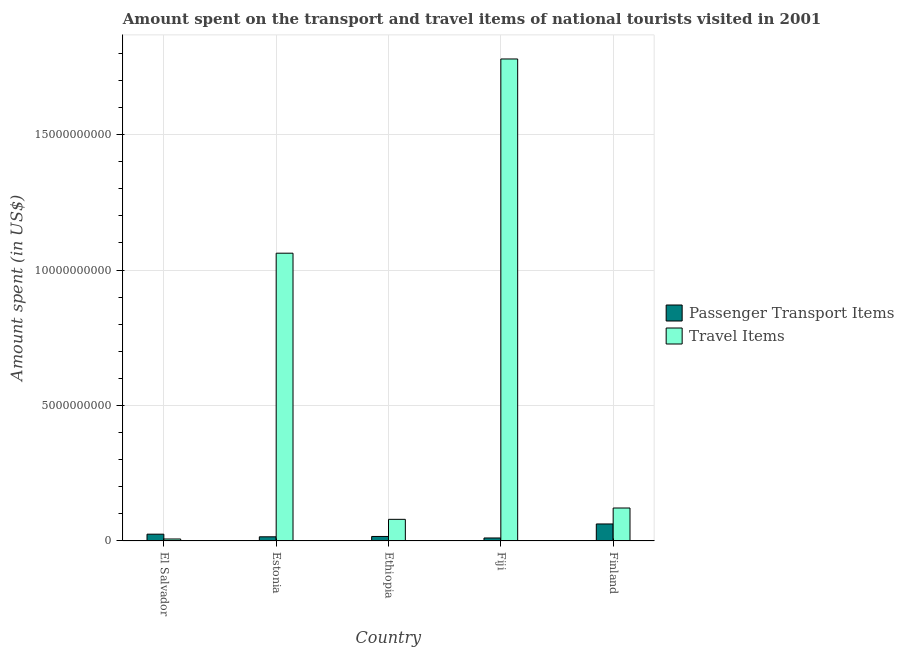How many different coloured bars are there?
Provide a succinct answer. 2. How many groups of bars are there?
Offer a very short reply. 5. Are the number of bars on each tick of the X-axis equal?
Give a very brief answer. Yes. How many bars are there on the 5th tick from the right?
Ensure brevity in your answer.  2. What is the label of the 3rd group of bars from the left?
Your answer should be very brief. Ethiopia. In how many cases, is the number of bars for a given country not equal to the number of legend labels?
Offer a terse response. 0. What is the amount spent in travel items in Ethiopia?
Provide a succinct answer. 7.99e+08. Across all countries, what is the maximum amount spent in travel items?
Provide a succinct answer. 1.78e+1. Across all countries, what is the minimum amount spent on passenger transport items?
Your answer should be compact. 1.11e+08. In which country was the amount spent in travel items minimum?
Your response must be concise. El Salvador. What is the total amount spent on passenger transport items in the graph?
Make the answer very short. 1.31e+09. What is the difference between the amount spent on passenger transport items in Fiji and that in Finland?
Provide a succinct answer. -5.17e+08. What is the difference between the amount spent in travel items in Ethiopia and the amount spent on passenger transport items in Finland?
Your answer should be compact. 1.71e+08. What is the average amount spent on passenger transport items per country?
Offer a terse response. 2.62e+08. What is the difference between the amount spent in travel items and amount spent on passenger transport items in Fiji?
Provide a succinct answer. 1.77e+1. In how many countries, is the amount spent on passenger transport items greater than 11000000000 US$?
Offer a terse response. 0. What is the ratio of the amount spent on passenger transport items in Ethiopia to that in Finland?
Offer a terse response. 0.27. Is the amount spent in travel items in El Salvador less than that in Fiji?
Provide a succinct answer. Yes. What is the difference between the highest and the second highest amount spent in travel items?
Make the answer very short. 7.17e+09. What is the difference between the highest and the lowest amount spent on passenger transport items?
Your answer should be very brief. 5.17e+08. What does the 1st bar from the left in Fiji represents?
Ensure brevity in your answer.  Passenger Transport Items. What does the 2nd bar from the right in El Salvador represents?
Keep it short and to the point. Passenger Transport Items. How many bars are there?
Offer a very short reply. 10. Does the graph contain grids?
Provide a succinct answer. Yes. What is the title of the graph?
Provide a short and direct response. Amount spent on the transport and travel items of national tourists visited in 2001. Does "Central government" appear as one of the legend labels in the graph?
Make the answer very short. No. What is the label or title of the X-axis?
Offer a very short reply. Country. What is the label or title of the Y-axis?
Provide a short and direct response. Amount spent (in US$). What is the Amount spent (in US$) of Passenger Transport Items in El Salvador?
Your response must be concise. 2.51e+08. What is the Amount spent (in US$) in Travel Items in El Salvador?
Make the answer very short. 7.30e+07. What is the Amount spent (in US$) in Passenger Transport Items in Estonia?
Provide a succinct answer. 1.54e+08. What is the Amount spent (in US$) in Travel Items in Estonia?
Keep it short and to the point. 1.06e+1. What is the Amount spent (in US$) in Passenger Transport Items in Ethiopia?
Your answer should be compact. 1.67e+08. What is the Amount spent (in US$) in Travel Items in Ethiopia?
Make the answer very short. 7.99e+08. What is the Amount spent (in US$) of Passenger Transport Items in Fiji?
Offer a very short reply. 1.11e+08. What is the Amount spent (in US$) of Travel Items in Fiji?
Give a very brief answer. 1.78e+1. What is the Amount spent (in US$) of Passenger Transport Items in Finland?
Give a very brief answer. 6.28e+08. What is the Amount spent (in US$) in Travel Items in Finland?
Offer a very short reply. 1.22e+09. Across all countries, what is the maximum Amount spent (in US$) of Passenger Transport Items?
Your answer should be compact. 6.28e+08. Across all countries, what is the maximum Amount spent (in US$) in Travel Items?
Keep it short and to the point. 1.78e+1. Across all countries, what is the minimum Amount spent (in US$) in Passenger Transport Items?
Keep it short and to the point. 1.11e+08. Across all countries, what is the minimum Amount spent (in US$) in Travel Items?
Provide a short and direct response. 7.30e+07. What is the total Amount spent (in US$) in Passenger Transport Items in the graph?
Provide a succinct answer. 1.31e+09. What is the total Amount spent (in US$) in Travel Items in the graph?
Make the answer very short. 3.05e+1. What is the difference between the Amount spent (in US$) in Passenger Transport Items in El Salvador and that in Estonia?
Make the answer very short. 9.70e+07. What is the difference between the Amount spent (in US$) of Travel Items in El Salvador and that in Estonia?
Ensure brevity in your answer.  -1.06e+1. What is the difference between the Amount spent (in US$) in Passenger Transport Items in El Salvador and that in Ethiopia?
Your answer should be compact. 8.40e+07. What is the difference between the Amount spent (in US$) of Travel Items in El Salvador and that in Ethiopia?
Keep it short and to the point. -7.26e+08. What is the difference between the Amount spent (in US$) of Passenger Transport Items in El Salvador and that in Fiji?
Make the answer very short. 1.40e+08. What is the difference between the Amount spent (in US$) in Travel Items in El Salvador and that in Fiji?
Provide a succinct answer. -1.77e+1. What is the difference between the Amount spent (in US$) in Passenger Transport Items in El Salvador and that in Finland?
Make the answer very short. -3.77e+08. What is the difference between the Amount spent (in US$) of Travel Items in El Salvador and that in Finland?
Give a very brief answer. -1.14e+09. What is the difference between the Amount spent (in US$) in Passenger Transport Items in Estonia and that in Ethiopia?
Make the answer very short. -1.30e+07. What is the difference between the Amount spent (in US$) in Travel Items in Estonia and that in Ethiopia?
Make the answer very short. 9.82e+09. What is the difference between the Amount spent (in US$) of Passenger Transport Items in Estonia and that in Fiji?
Your answer should be very brief. 4.30e+07. What is the difference between the Amount spent (in US$) in Travel Items in Estonia and that in Fiji?
Give a very brief answer. -7.17e+09. What is the difference between the Amount spent (in US$) of Passenger Transport Items in Estonia and that in Finland?
Your answer should be very brief. -4.74e+08. What is the difference between the Amount spent (in US$) of Travel Items in Estonia and that in Finland?
Make the answer very short. 9.41e+09. What is the difference between the Amount spent (in US$) in Passenger Transport Items in Ethiopia and that in Fiji?
Keep it short and to the point. 5.60e+07. What is the difference between the Amount spent (in US$) in Travel Items in Ethiopia and that in Fiji?
Give a very brief answer. -1.70e+1. What is the difference between the Amount spent (in US$) of Passenger Transport Items in Ethiopia and that in Finland?
Your response must be concise. -4.61e+08. What is the difference between the Amount spent (in US$) in Travel Items in Ethiopia and that in Finland?
Offer a very short reply. -4.18e+08. What is the difference between the Amount spent (in US$) of Passenger Transport Items in Fiji and that in Finland?
Offer a terse response. -5.17e+08. What is the difference between the Amount spent (in US$) of Travel Items in Fiji and that in Finland?
Provide a succinct answer. 1.66e+1. What is the difference between the Amount spent (in US$) of Passenger Transport Items in El Salvador and the Amount spent (in US$) of Travel Items in Estonia?
Offer a very short reply. -1.04e+1. What is the difference between the Amount spent (in US$) of Passenger Transport Items in El Salvador and the Amount spent (in US$) of Travel Items in Ethiopia?
Keep it short and to the point. -5.48e+08. What is the difference between the Amount spent (in US$) in Passenger Transport Items in El Salvador and the Amount spent (in US$) in Travel Items in Fiji?
Give a very brief answer. -1.75e+1. What is the difference between the Amount spent (in US$) in Passenger Transport Items in El Salvador and the Amount spent (in US$) in Travel Items in Finland?
Offer a terse response. -9.66e+08. What is the difference between the Amount spent (in US$) of Passenger Transport Items in Estonia and the Amount spent (in US$) of Travel Items in Ethiopia?
Offer a very short reply. -6.45e+08. What is the difference between the Amount spent (in US$) in Passenger Transport Items in Estonia and the Amount spent (in US$) in Travel Items in Fiji?
Provide a succinct answer. -1.76e+1. What is the difference between the Amount spent (in US$) in Passenger Transport Items in Estonia and the Amount spent (in US$) in Travel Items in Finland?
Give a very brief answer. -1.06e+09. What is the difference between the Amount spent (in US$) in Passenger Transport Items in Ethiopia and the Amount spent (in US$) in Travel Items in Fiji?
Your answer should be very brief. -1.76e+1. What is the difference between the Amount spent (in US$) of Passenger Transport Items in Ethiopia and the Amount spent (in US$) of Travel Items in Finland?
Provide a short and direct response. -1.05e+09. What is the difference between the Amount spent (in US$) of Passenger Transport Items in Fiji and the Amount spent (in US$) of Travel Items in Finland?
Offer a very short reply. -1.11e+09. What is the average Amount spent (in US$) of Passenger Transport Items per country?
Provide a short and direct response. 2.62e+08. What is the average Amount spent (in US$) in Travel Items per country?
Your answer should be very brief. 6.10e+09. What is the difference between the Amount spent (in US$) of Passenger Transport Items and Amount spent (in US$) of Travel Items in El Salvador?
Make the answer very short. 1.78e+08. What is the difference between the Amount spent (in US$) in Passenger Transport Items and Amount spent (in US$) in Travel Items in Estonia?
Provide a succinct answer. -1.05e+1. What is the difference between the Amount spent (in US$) in Passenger Transport Items and Amount spent (in US$) in Travel Items in Ethiopia?
Your answer should be compact. -6.32e+08. What is the difference between the Amount spent (in US$) in Passenger Transport Items and Amount spent (in US$) in Travel Items in Fiji?
Provide a succinct answer. -1.77e+1. What is the difference between the Amount spent (in US$) of Passenger Transport Items and Amount spent (in US$) of Travel Items in Finland?
Provide a short and direct response. -5.89e+08. What is the ratio of the Amount spent (in US$) in Passenger Transport Items in El Salvador to that in Estonia?
Your answer should be compact. 1.63. What is the ratio of the Amount spent (in US$) of Travel Items in El Salvador to that in Estonia?
Offer a very short reply. 0.01. What is the ratio of the Amount spent (in US$) in Passenger Transport Items in El Salvador to that in Ethiopia?
Your answer should be compact. 1.5. What is the ratio of the Amount spent (in US$) in Travel Items in El Salvador to that in Ethiopia?
Your response must be concise. 0.09. What is the ratio of the Amount spent (in US$) of Passenger Transport Items in El Salvador to that in Fiji?
Keep it short and to the point. 2.26. What is the ratio of the Amount spent (in US$) of Travel Items in El Salvador to that in Fiji?
Offer a very short reply. 0. What is the ratio of the Amount spent (in US$) of Passenger Transport Items in El Salvador to that in Finland?
Keep it short and to the point. 0.4. What is the ratio of the Amount spent (in US$) of Passenger Transport Items in Estonia to that in Ethiopia?
Your answer should be very brief. 0.92. What is the ratio of the Amount spent (in US$) in Travel Items in Estonia to that in Ethiopia?
Your answer should be very brief. 13.3. What is the ratio of the Amount spent (in US$) of Passenger Transport Items in Estonia to that in Fiji?
Make the answer very short. 1.39. What is the ratio of the Amount spent (in US$) in Travel Items in Estonia to that in Fiji?
Keep it short and to the point. 0.6. What is the ratio of the Amount spent (in US$) of Passenger Transport Items in Estonia to that in Finland?
Offer a very short reply. 0.25. What is the ratio of the Amount spent (in US$) of Travel Items in Estonia to that in Finland?
Offer a terse response. 8.73. What is the ratio of the Amount spent (in US$) of Passenger Transport Items in Ethiopia to that in Fiji?
Keep it short and to the point. 1.5. What is the ratio of the Amount spent (in US$) in Travel Items in Ethiopia to that in Fiji?
Provide a short and direct response. 0.04. What is the ratio of the Amount spent (in US$) of Passenger Transport Items in Ethiopia to that in Finland?
Ensure brevity in your answer.  0.27. What is the ratio of the Amount spent (in US$) in Travel Items in Ethiopia to that in Finland?
Offer a very short reply. 0.66. What is the ratio of the Amount spent (in US$) of Passenger Transport Items in Fiji to that in Finland?
Your answer should be compact. 0.18. What is the ratio of the Amount spent (in US$) in Travel Items in Fiji to that in Finland?
Keep it short and to the point. 14.62. What is the difference between the highest and the second highest Amount spent (in US$) in Passenger Transport Items?
Provide a succinct answer. 3.77e+08. What is the difference between the highest and the second highest Amount spent (in US$) of Travel Items?
Provide a succinct answer. 7.17e+09. What is the difference between the highest and the lowest Amount spent (in US$) in Passenger Transport Items?
Make the answer very short. 5.17e+08. What is the difference between the highest and the lowest Amount spent (in US$) of Travel Items?
Your answer should be very brief. 1.77e+1. 